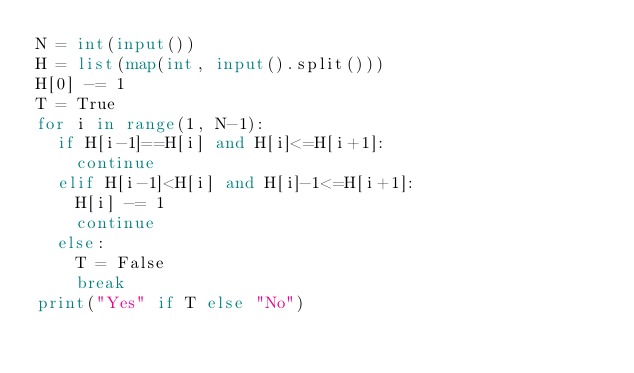<code> <loc_0><loc_0><loc_500><loc_500><_Python_>N = int(input())
H = list(map(int, input().split()))
H[0] -= 1
T = True
for i in range(1, N-1):
  if H[i-1]==H[i] and H[i]<=H[i+1]:
    continue
  elif H[i-1]<H[i] and H[i]-1<=H[i+1]:
    H[i] -= 1
    continue
  else:
    T = False
    break
print("Yes" if T else "No")
</code> 